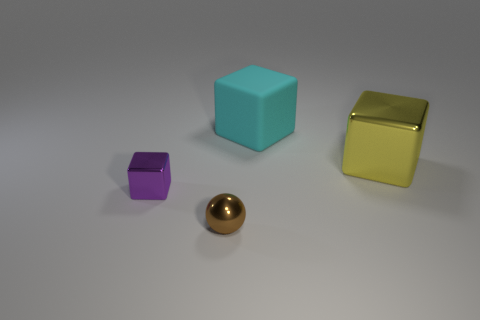Add 1 shiny things. How many objects exist? 5 Subtract all balls. How many objects are left? 3 Subtract all small brown balls. Subtract all big rubber cubes. How many objects are left? 2 Add 2 small brown metal balls. How many small brown metal balls are left? 3 Add 3 gray matte cubes. How many gray matte cubes exist? 3 Subtract 0 green cylinders. How many objects are left? 4 